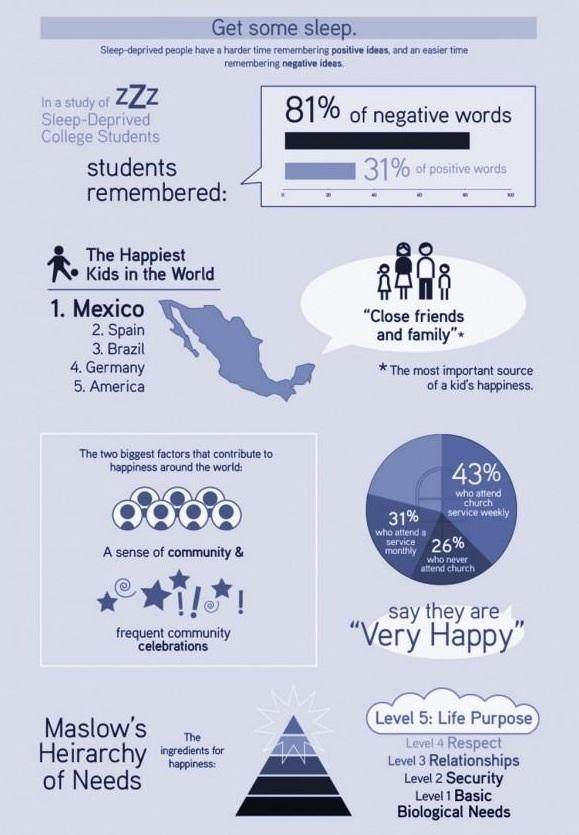What are the factors that affect happiness around the world?
Answer the question with a short phrase. A sense of community, frequent community celebrations What is the most important source of a kid's happiness? Close friends and family What percentage of people who attend a service monthly and weekly together are very happy? 74% 